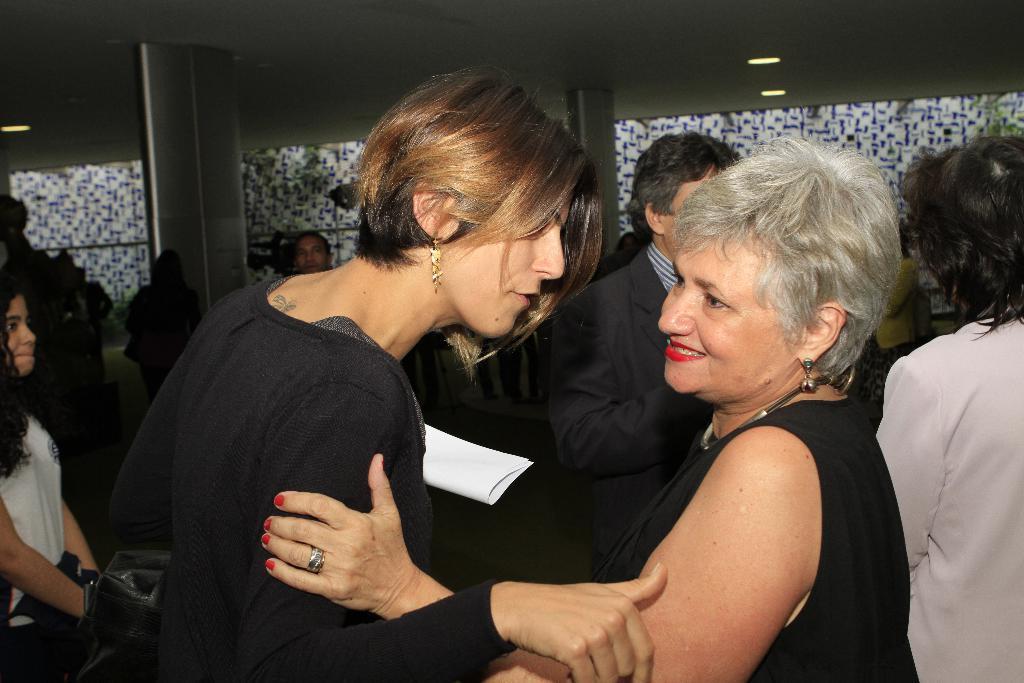In one or two sentences, can you explain what this image depicts? In this image in a hall there are many people. On the ceiling there are lights. In the foreground two ladies are standing wearing black dress. 